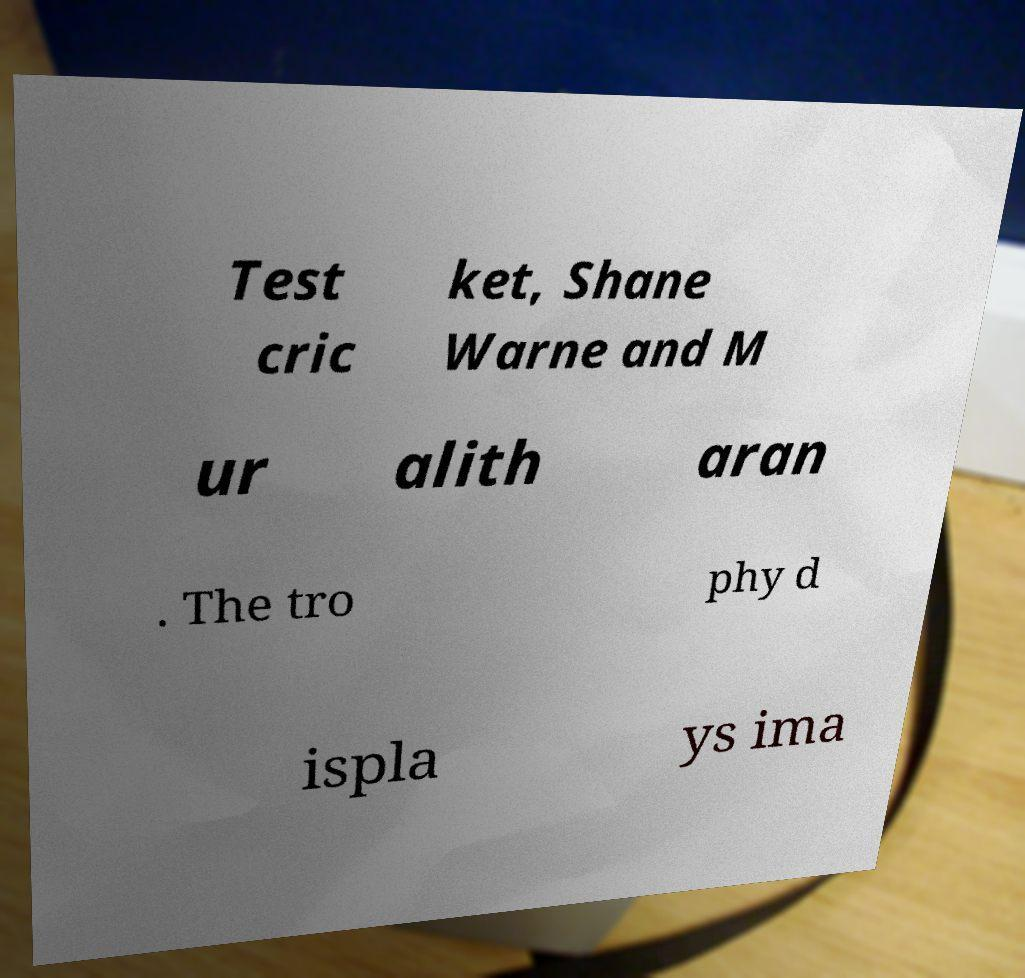I need the written content from this picture converted into text. Can you do that? Test cric ket, Shane Warne and M ur alith aran . The tro phy d ispla ys ima 